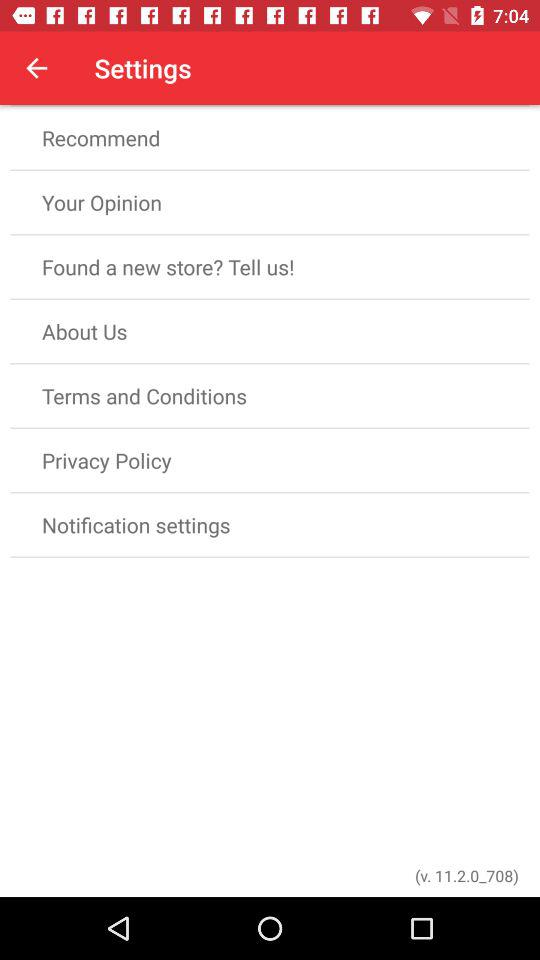What is the version? The version is 11.2.0_708. 